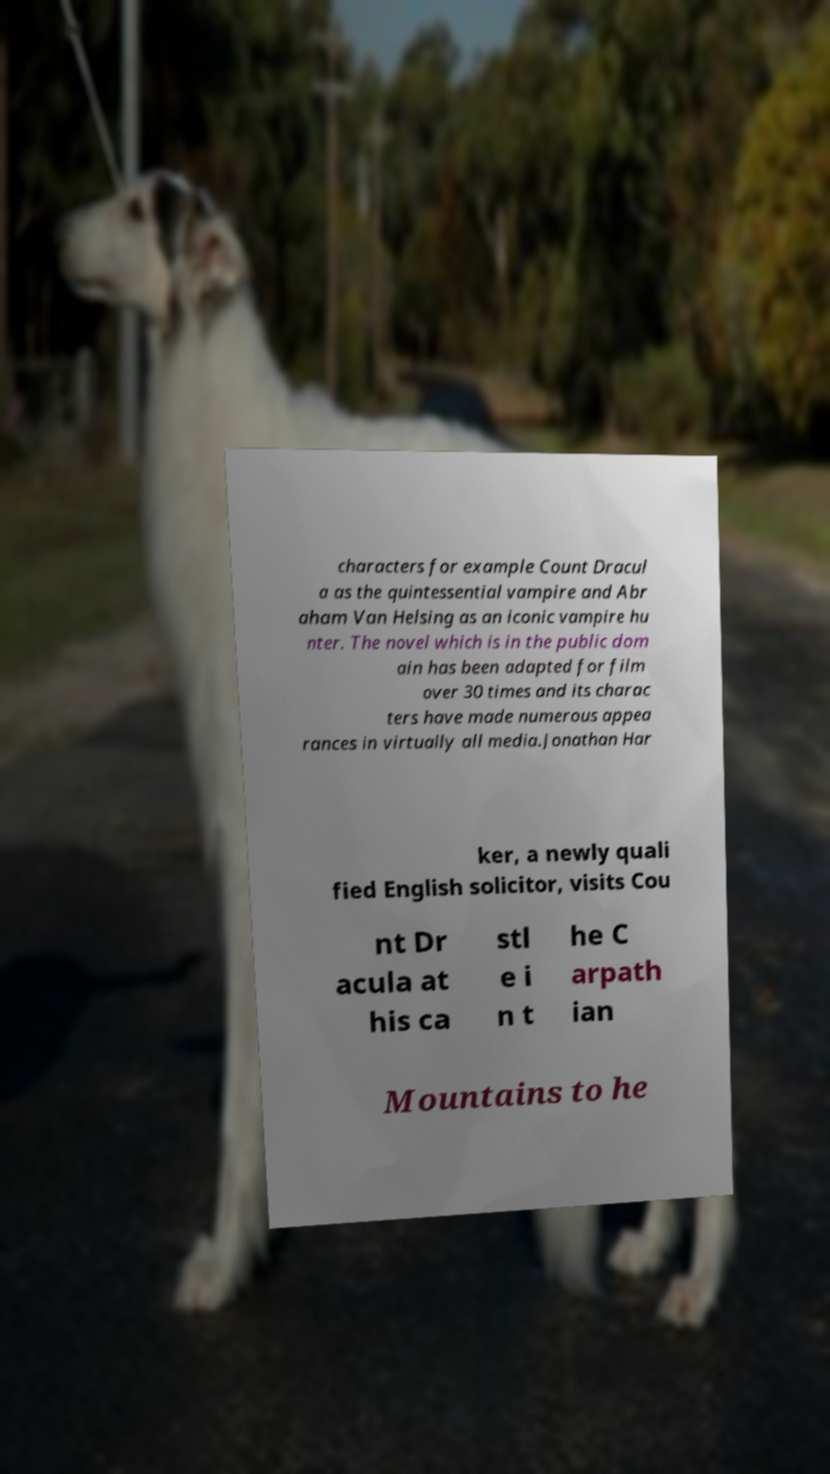Could you assist in decoding the text presented in this image and type it out clearly? characters for example Count Dracul a as the quintessential vampire and Abr aham Van Helsing as an iconic vampire hu nter. The novel which is in the public dom ain has been adapted for film over 30 times and its charac ters have made numerous appea rances in virtually all media.Jonathan Har ker, a newly quali fied English solicitor, visits Cou nt Dr acula at his ca stl e i n t he C arpath ian Mountains to he 